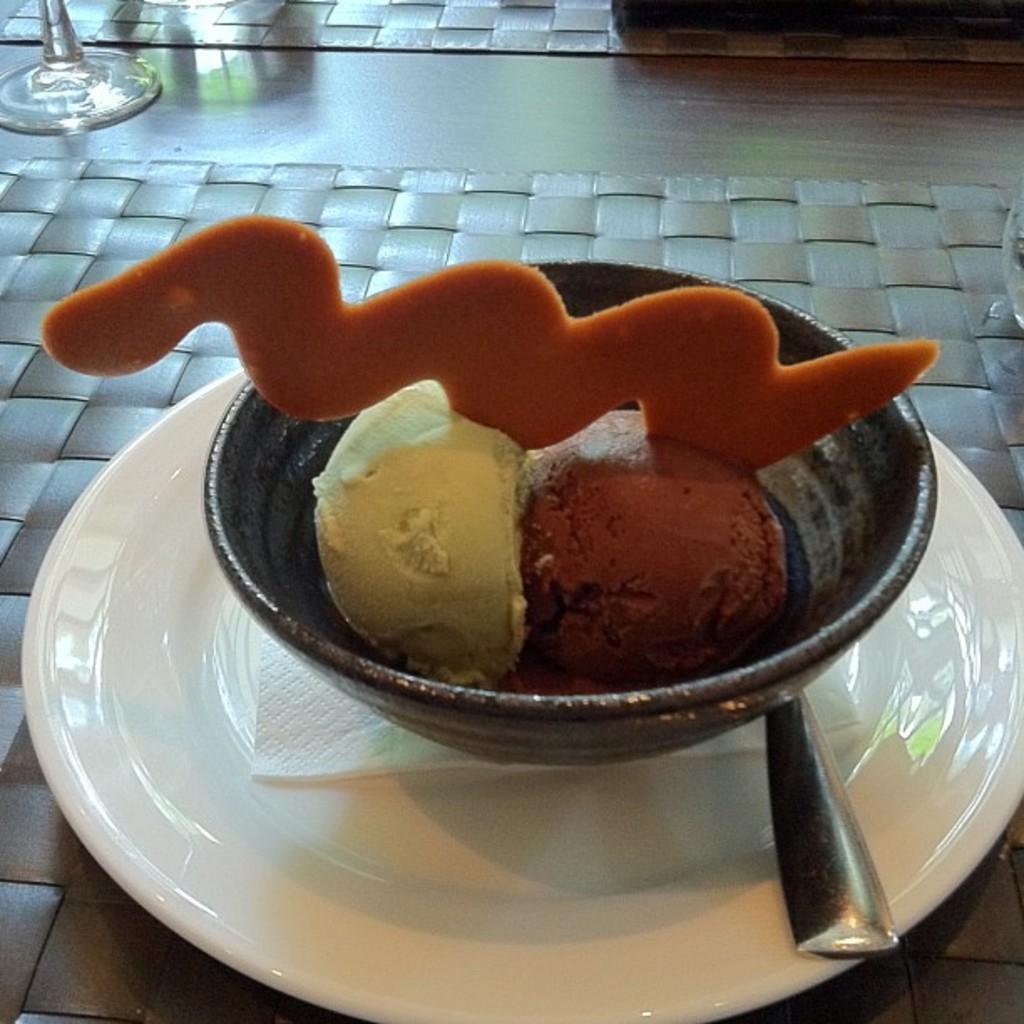In one or two sentences, can you explain what this image depicts? In this picture there is a bowl in the center of the image, on a plate, which contains ice cream in it and there is a glass in the top left side of the image and there is a spoon and tissue in the plate. 